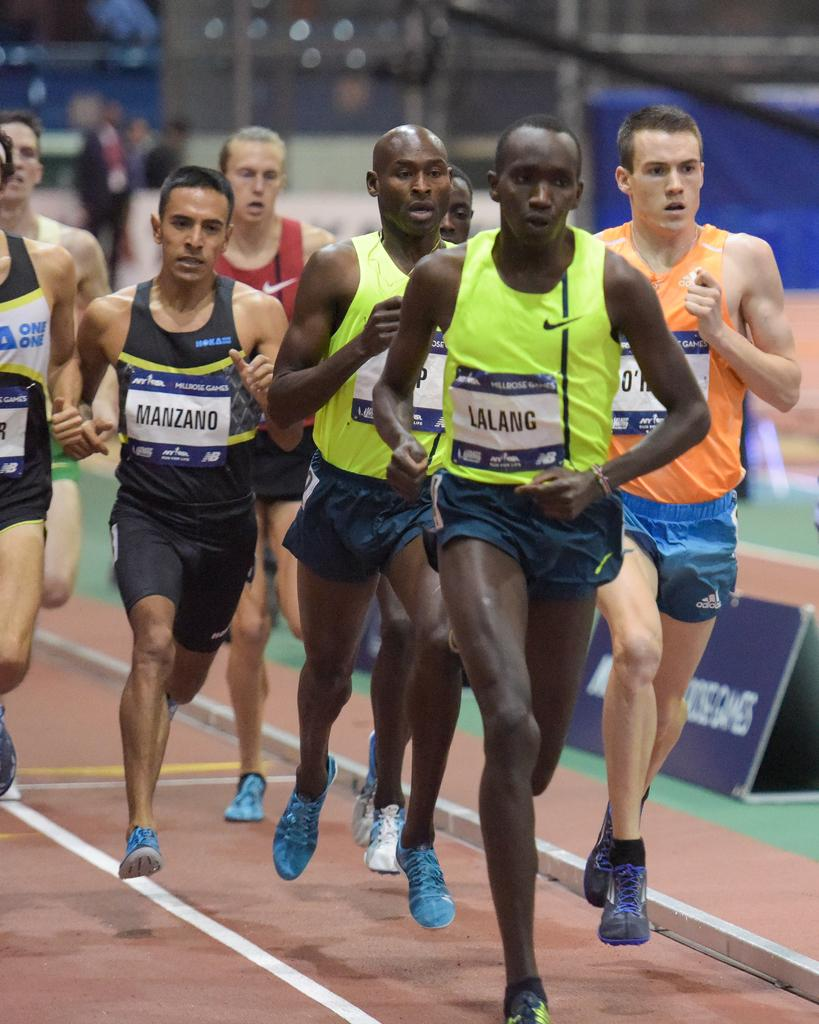Provide a one-sentence caption for the provided image. The runner named Lalang is leading the pack of runners on the track. 